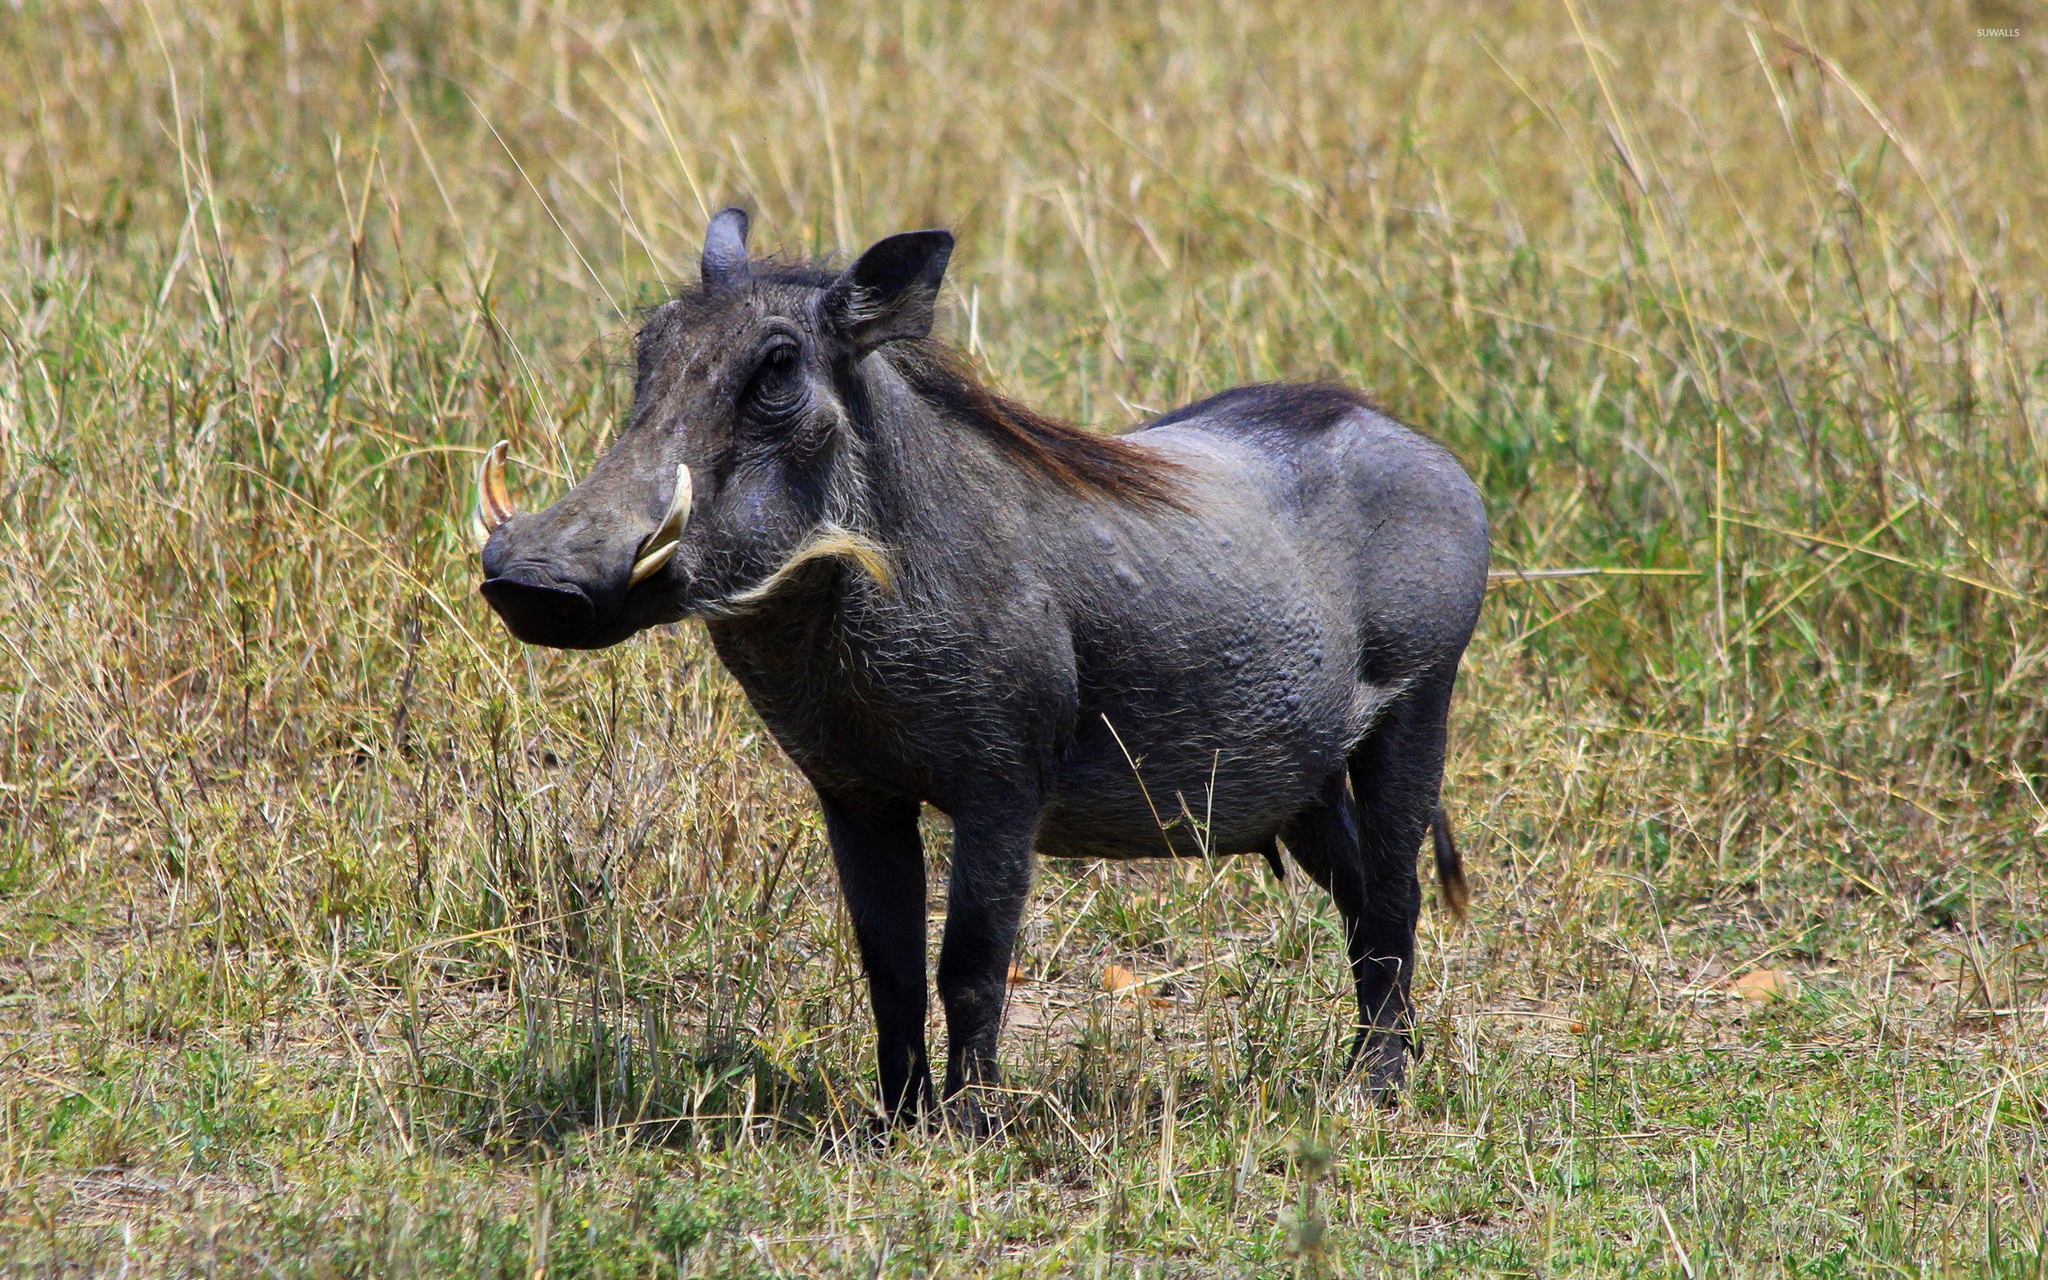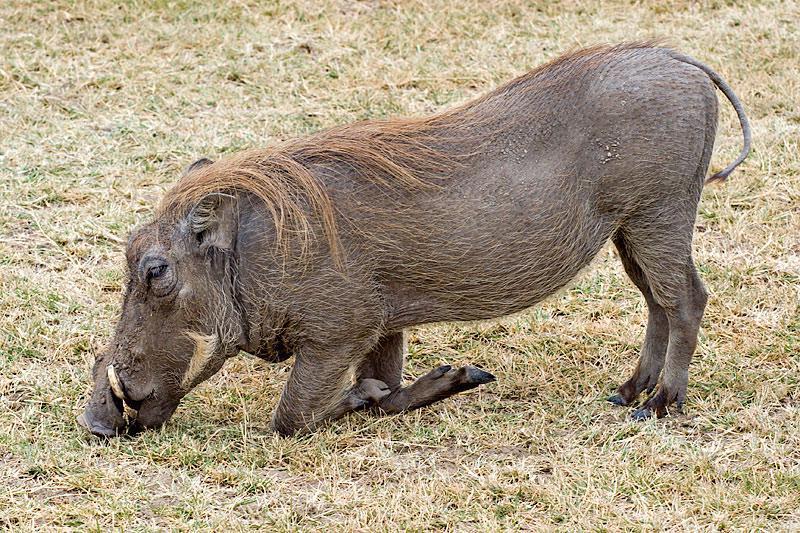The first image is the image on the left, the second image is the image on the right. Analyze the images presented: Is the assertion "There are more than two animals total." valid? Answer yes or no. No. 